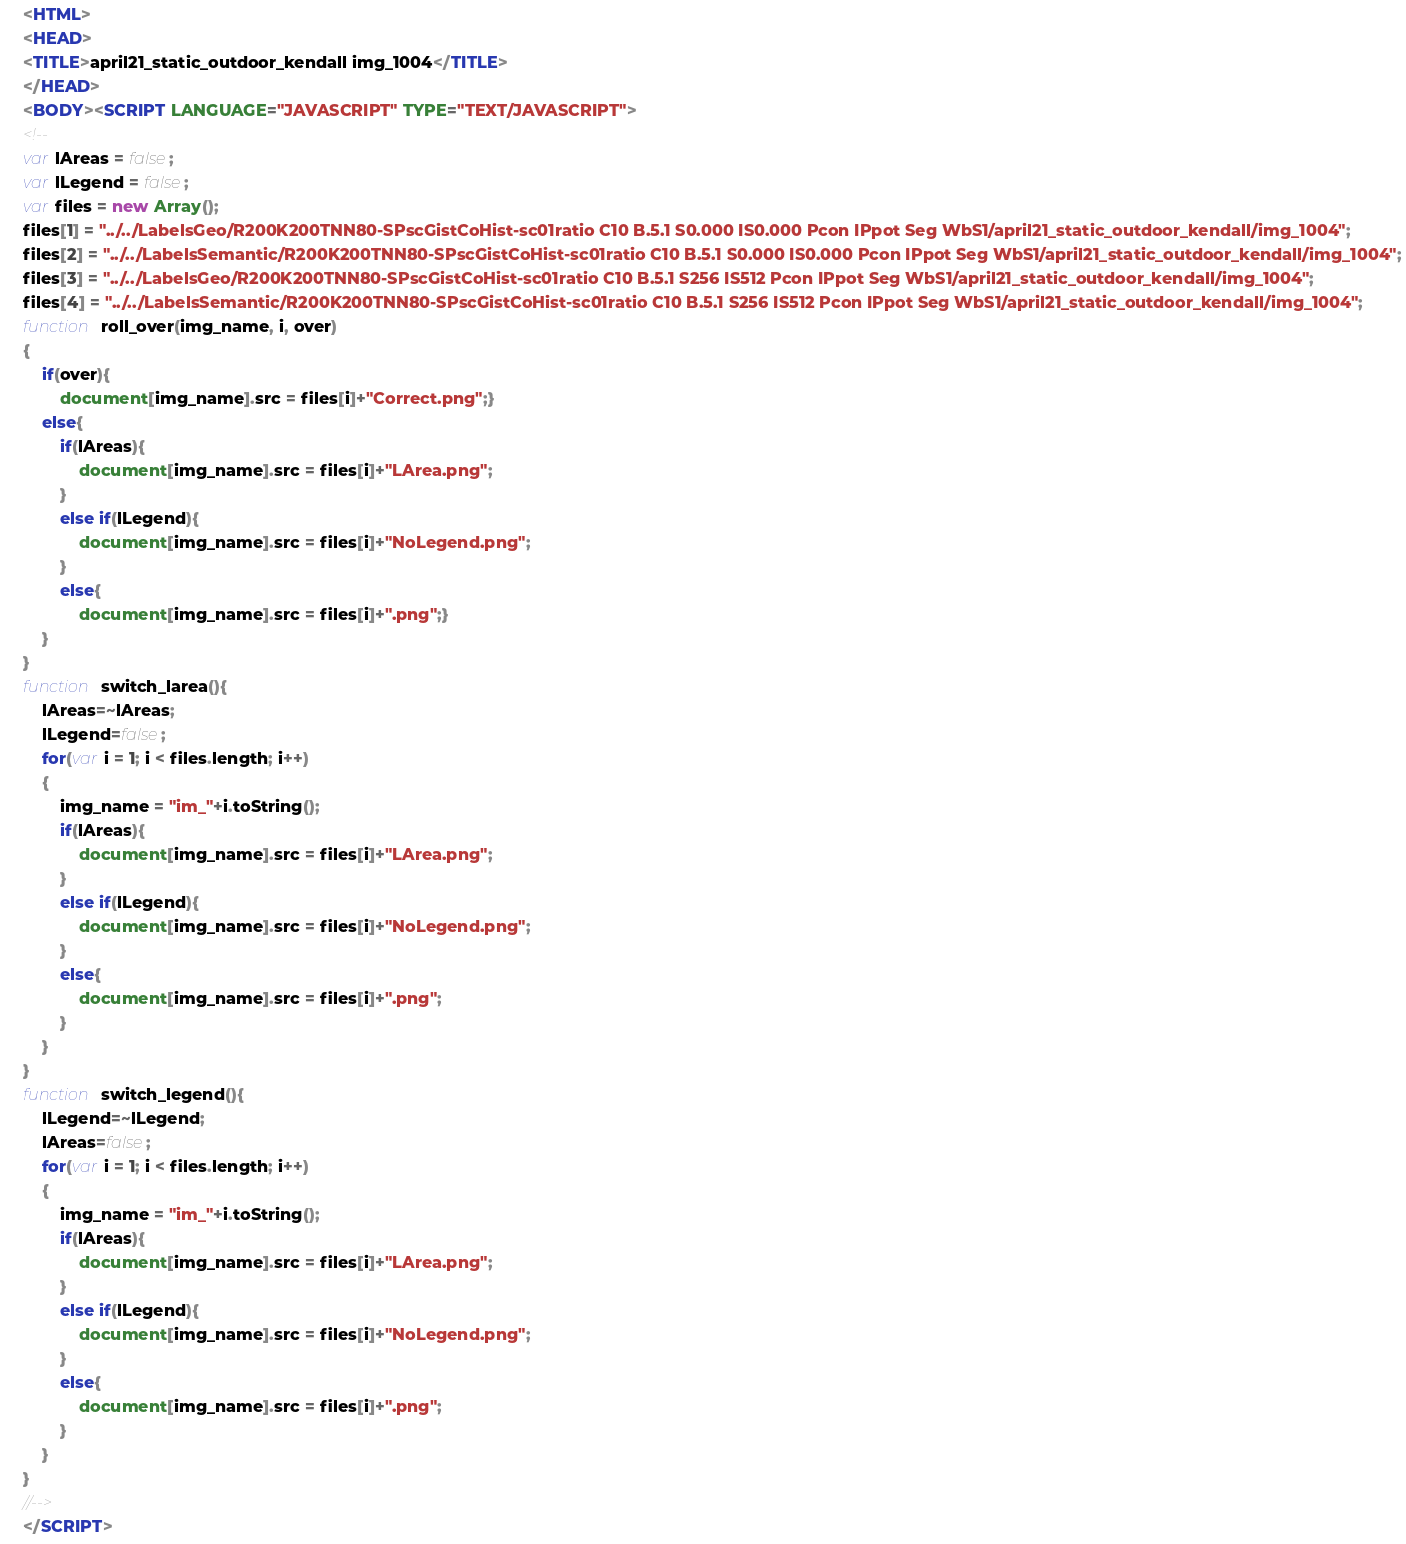Convert code to text. <code><loc_0><loc_0><loc_500><loc_500><_HTML_><HTML>
<HEAD>
<TITLE>april21_static_outdoor_kendall img_1004</TITLE>
</HEAD>
<BODY><SCRIPT LANGUAGE="JAVASCRIPT" TYPE="TEXT/JAVASCRIPT">
<!--
var lAreas = false;
var lLegend = false;
var files = new Array();
files[1] = "../../LabelsGeo/R200K200TNN80-SPscGistCoHist-sc01ratio C10 B.5.1 S0.000 IS0.000 Pcon IPpot Seg WbS1/april21_static_outdoor_kendall/img_1004";
files[2] = "../../LabelsSemantic/R200K200TNN80-SPscGistCoHist-sc01ratio C10 B.5.1 S0.000 IS0.000 Pcon IPpot Seg WbS1/april21_static_outdoor_kendall/img_1004";
files[3] = "../../LabelsGeo/R200K200TNN80-SPscGistCoHist-sc01ratio C10 B.5.1 S256 IS512 Pcon IPpot Seg WbS1/april21_static_outdoor_kendall/img_1004";
files[4] = "../../LabelsSemantic/R200K200TNN80-SPscGistCoHist-sc01ratio C10 B.5.1 S256 IS512 Pcon IPpot Seg WbS1/april21_static_outdoor_kendall/img_1004";
function roll_over(img_name, i, over)
{
	if(over){
		document[img_name].src = files[i]+"Correct.png";}
	else{
		if(lAreas){
			document[img_name].src = files[i]+"LArea.png";
		}
		else if(lLegend){
			document[img_name].src = files[i]+"NoLegend.png";
		}
		else{
			document[img_name].src = files[i]+".png";}
	}
}
function switch_larea(){
	lAreas=~lAreas;
	lLegend=false;
	for(var i = 1; i < files.length; i++)
	{
		img_name = "im_"+i.toString();
		if(lAreas){
			document[img_name].src = files[i]+"LArea.png";
		}
		else if(lLegend){
			document[img_name].src = files[i]+"NoLegend.png";
		}
		else{
			document[img_name].src = files[i]+".png";
		}
	}
}
function switch_legend(){
	lLegend=~lLegend;
	lAreas=false;
	for(var i = 1; i < files.length; i++)
	{
		img_name = "im_"+i.toString();
		if(lAreas){
			document[img_name].src = files[i]+"LArea.png";
		}
		else if(lLegend){
			document[img_name].src = files[i]+"NoLegend.png";
		}
		else{
			document[img_name].src = files[i]+".png";
		}
	}
}
//-->
</SCRIPT></code> 